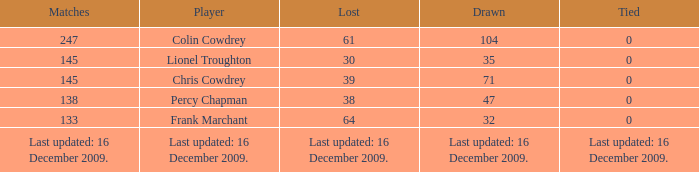I want to know the tie for drawn of 47 0.0. 